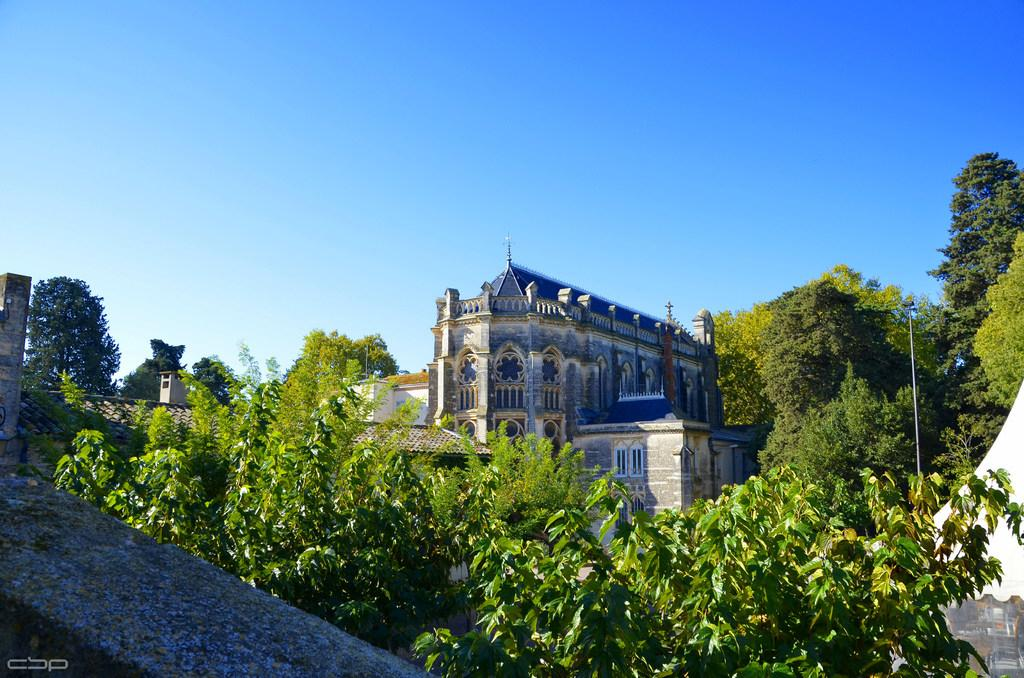What type of natural elements are present in the image? There are many trees in the image. What type of man-made structures can be seen in the image? There are buildings with windows in the image. What part of the natural environment is visible in the image? The sky is visible in the background of the image. What type of furniture can be seen in the image? There is no furniture present in the image; it features trees and buildings with windows. What page of a book is the image taken from? The image is not a part of a book, so there is no specific page associated with it. 